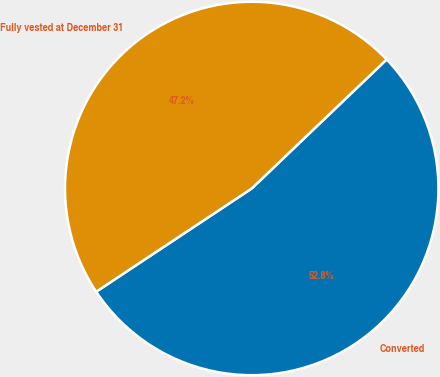<chart> <loc_0><loc_0><loc_500><loc_500><pie_chart><fcel>Converted<fcel>Fully vested at December 31<nl><fcel>52.82%<fcel>47.18%<nl></chart> 